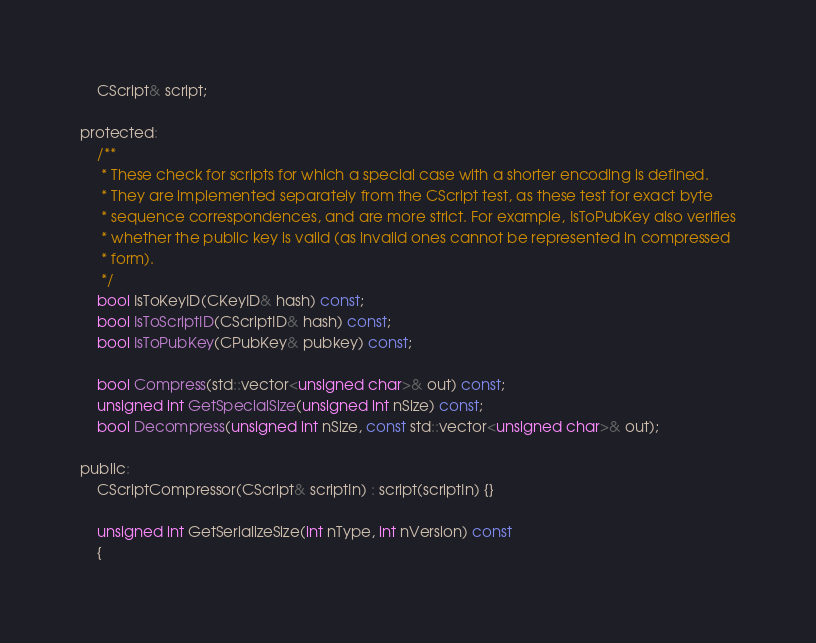<code> <loc_0><loc_0><loc_500><loc_500><_C_>    CScript& script;

protected:
    /**
     * These check for scripts for which a special case with a shorter encoding is defined.
     * They are implemented separately from the CScript test, as these test for exact byte
     * sequence correspondences, and are more strict. For example, IsToPubKey also verifies
     * whether the public key is valid (as invalid ones cannot be represented in compressed
     * form).
     */
    bool IsToKeyID(CKeyID& hash) const;
    bool IsToScriptID(CScriptID& hash) const;
    bool IsToPubKey(CPubKey& pubkey) const;

    bool Compress(std::vector<unsigned char>& out) const;
    unsigned int GetSpecialSize(unsigned int nSize) const;
    bool Decompress(unsigned int nSize, const std::vector<unsigned char>& out);

public:
    CScriptCompressor(CScript& scriptIn) : script(scriptIn) {}

    unsigned int GetSerializeSize(int nType, int nVersion) const
    {</code> 